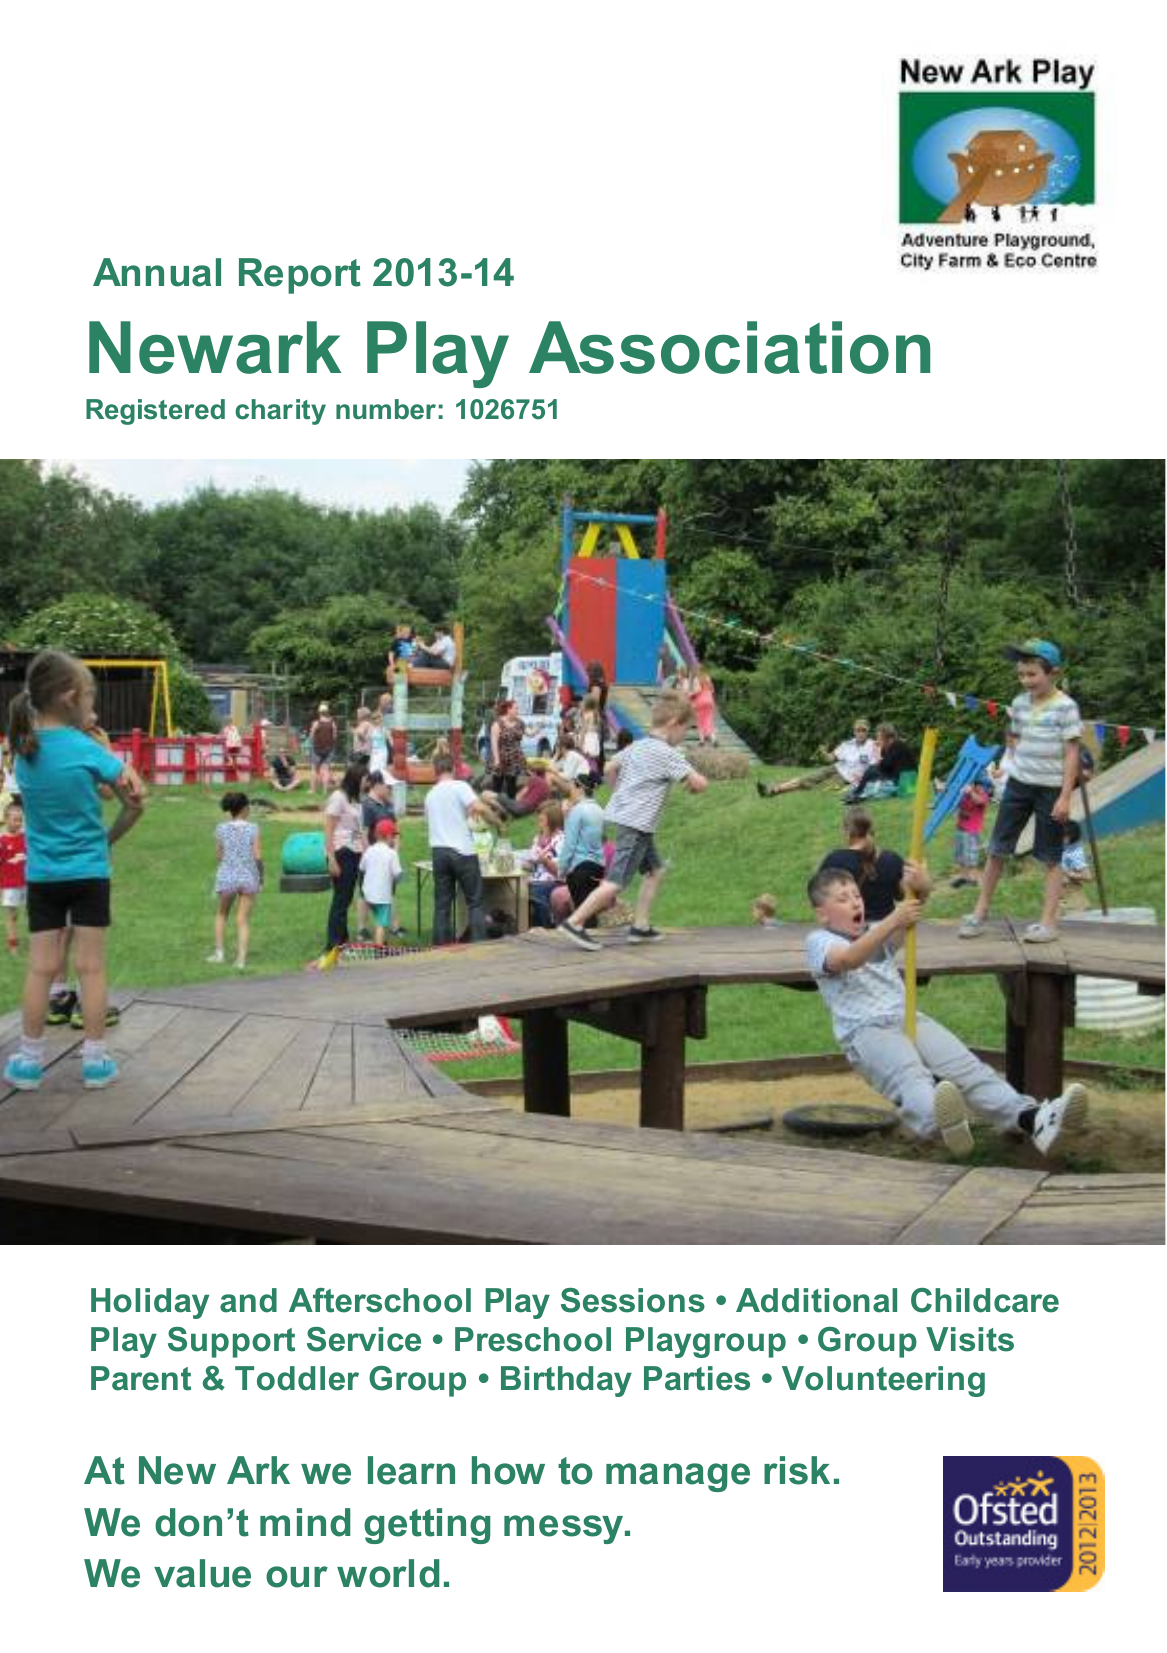What is the value for the charity_name?
Answer the question using a single word or phrase. Newark Play Association Ltd. 